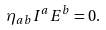<formula> <loc_0><loc_0><loc_500><loc_500>\eta _ { a b } I ^ { a } E ^ { b } = 0 .</formula> 